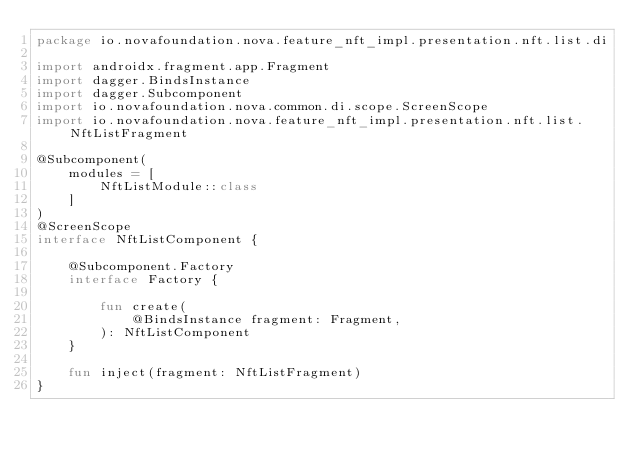<code> <loc_0><loc_0><loc_500><loc_500><_Kotlin_>package io.novafoundation.nova.feature_nft_impl.presentation.nft.list.di

import androidx.fragment.app.Fragment
import dagger.BindsInstance
import dagger.Subcomponent
import io.novafoundation.nova.common.di.scope.ScreenScope
import io.novafoundation.nova.feature_nft_impl.presentation.nft.list.NftListFragment

@Subcomponent(
    modules = [
        NftListModule::class
    ]
)
@ScreenScope
interface NftListComponent {

    @Subcomponent.Factory
    interface Factory {

        fun create(
            @BindsInstance fragment: Fragment,
        ): NftListComponent
    }

    fun inject(fragment: NftListFragment)
}
</code> 